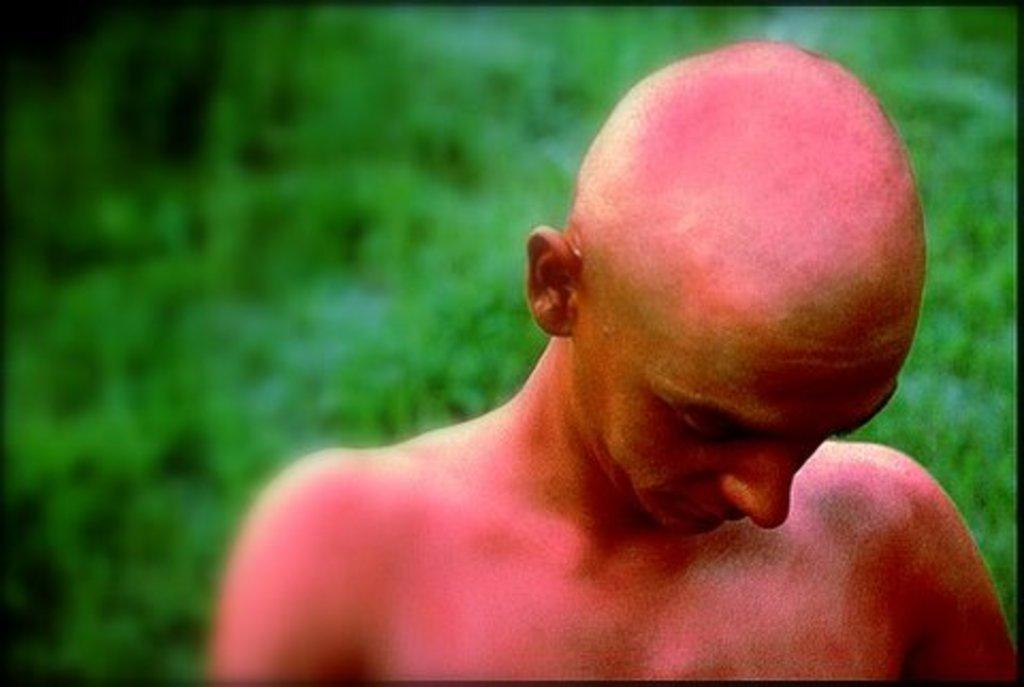What is the appearance of the man in the image? The man in the image is bald and shirtless. What is the man's position in the image? The man is standing in front of the image. How would you describe the background of the image? The background of the image is green and blurred. How does the man control the bottle in the image? There is no bottle present in the image, so the man cannot control it. 